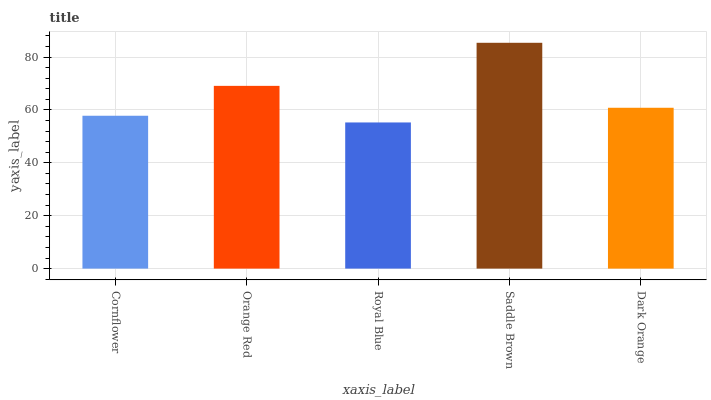Is Royal Blue the minimum?
Answer yes or no. Yes. Is Saddle Brown the maximum?
Answer yes or no. Yes. Is Orange Red the minimum?
Answer yes or no. No. Is Orange Red the maximum?
Answer yes or no. No. Is Orange Red greater than Cornflower?
Answer yes or no. Yes. Is Cornflower less than Orange Red?
Answer yes or no. Yes. Is Cornflower greater than Orange Red?
Answer yes or no. No. Is Orange Red less than Cornflower?
Answer yes or no. No. Is Dark Orange the high median?
Answer yes or no. Yes. Is Dark Orange the low median?
Answer yes or no. Yes. Is Saddle Brown the high median?
Answer yes or no. No. Is Royal Blue the low median?
Answer yes or no. No. 